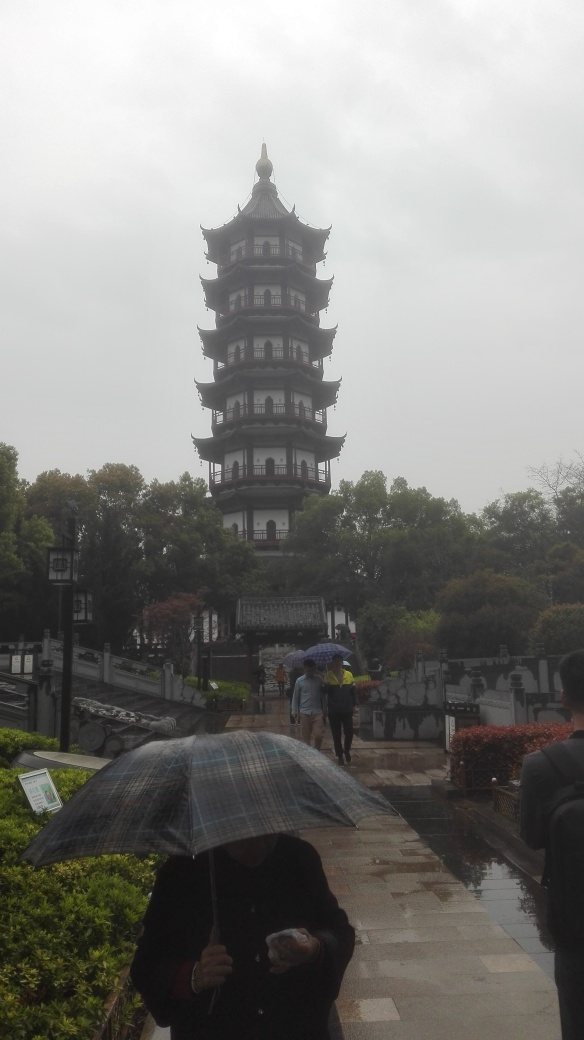What is the architectural style of the tower in the picture? The tower in the image appears to be designed in an East Asian architectural style, possibly Chinese. It features multiple stories with upward-curving eaves, typically found in the regions' traditional buildings. 